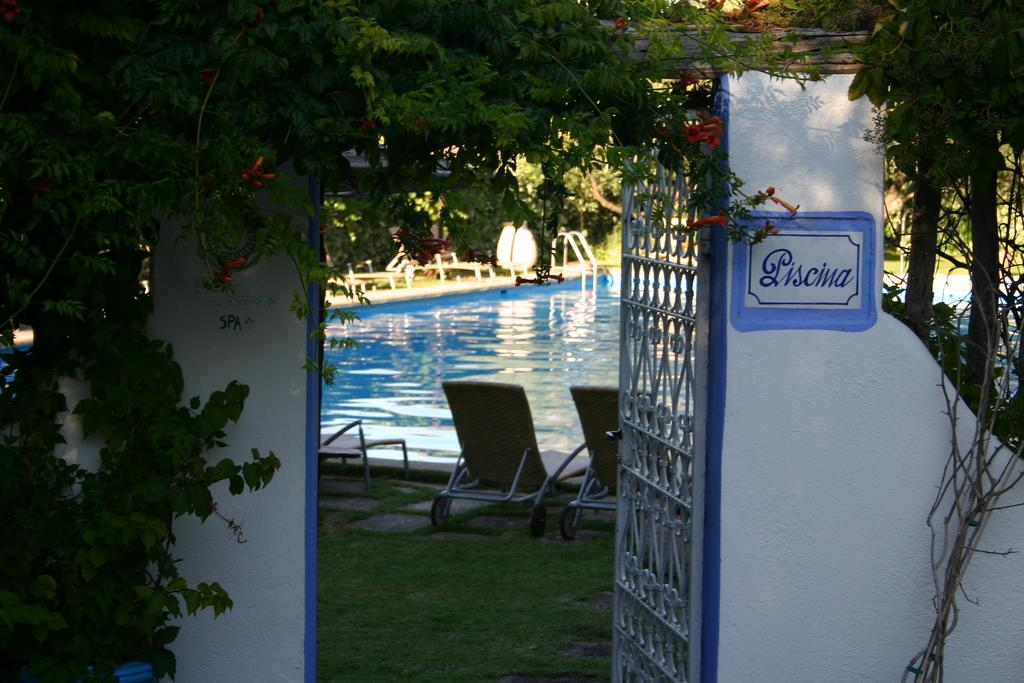What type of plant life can be seen in the image? There are leaves and flowers in the image. What type of structure is present in the image? There is a door in the image. What is on the wall in the image? There is a board on the wall in the image. What type of ground surface is visible in the image? There is grass in the image. What type of furniture is present in the image? There are chairs in the image. What type of liquid is visible in the image? There is water visible in the image. What can be seen in the background of the image? In the background of the image, there are leaves and other objects. What type of creature is hiding in the box in the image? There is no box or creature present in the image. What type of sound can be heard during the thunderstorm in the image? There is no thunderstorm present in the image. 